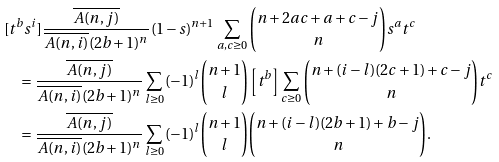Convert formula to latex. <formula><loc_0><loc_0><loc_500><loc_500>& [ t ^ { b } s ^ { i } ] \frac { \overline { A ( n , j ) } } { \overline { A ( n , i ) } ( 2 b + 1 ) ^ { n } } ( 1 - s ) ^ { n + 1 } \sum _ { a , c \geq 0 } { n + 2 a c + a + c - j \choose n } s ^ { a } t ^ { c } \\ & \quad = \frac { \overline { A ( n , j ) } } { \overline { A ( n , i ) } ( 2 b + 1 ) ^ { n } } \sum _ { l \geq 0 } ( - 1 ) ^ { l } { n + 1 \choose l } \left [ t ^ { b } \right ] \sum _ { c \geq 0 } { n + ( i - l ) ( 2 c + 1 ) + c - j \choose n } t ^ { c } \\ & \quad = \frac { \overline { A ( n , j ) } } { \overline { A ( n , i ) } ( 2 b + 1 ) ^ { n } } \sum _ { l \geq 0 } ( - 1 ) ^ { l } { n + 1 \choose l } { n + ( i - l ) ( 2 b + 1 ) + b - j \choose n } .</formula> 